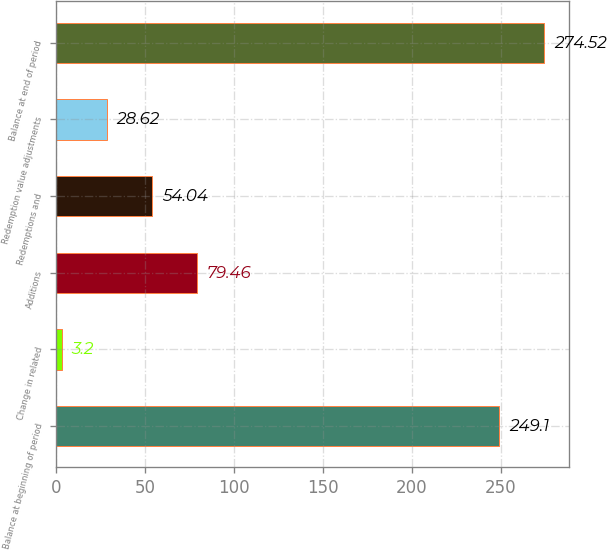Convert chart. <chart><loc_0><loc_0><loc_500><loc_500><bar_chart><fcel>Balance at beginning of period<fcel>Change in related<fcel>Additions<fcel>Redemptions and<fcel>Redemption value adjustments<fcel>Balance at end of period<nl><fcel>249.1<fcel>3.2<fcel>79.46<fcel>54.04<fcel>28.62<fcel>274.52<nl></chart> 